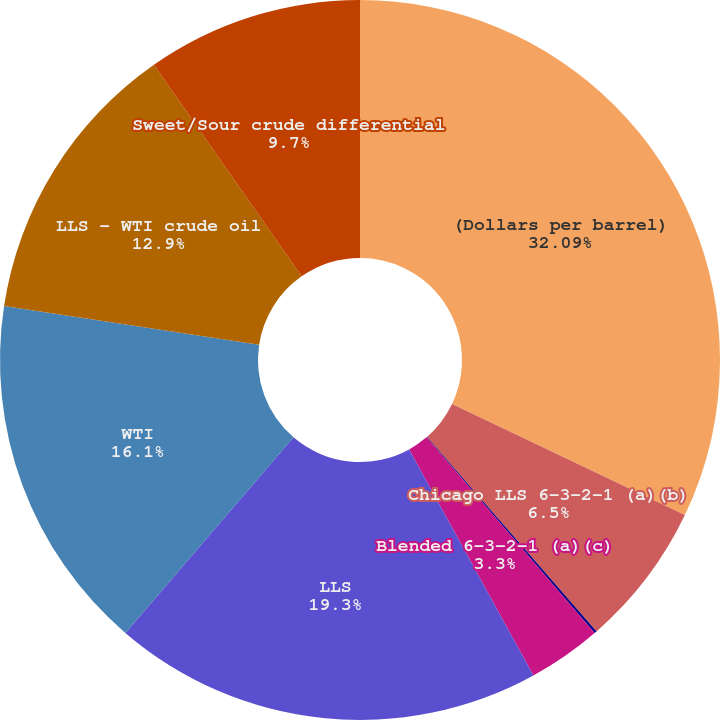Convert chart. <chart><loc_0><loc_0><loc_500><loc_500><pie_chart><fcel>(Dollars per barrel)<fcel>Chicago LLS 6-3-2-1 (a)(b)<fcel>USGC LLS 6-3-2-1 (a)<fcel>Blended 6-3-2-1 (a)(c)<fcel>LLS<fcel>WTI<fcel>LLS - WTI crude oil<fcel>Sweet/Sour crude differential<nl><fcel>32.09%<fcel>6.5%<fcel>0.11%<fcel>3.3%<fcel>19.3%<fcel>16.1%<fcel>12.9%<fcel>9.7%<nl></chart> 